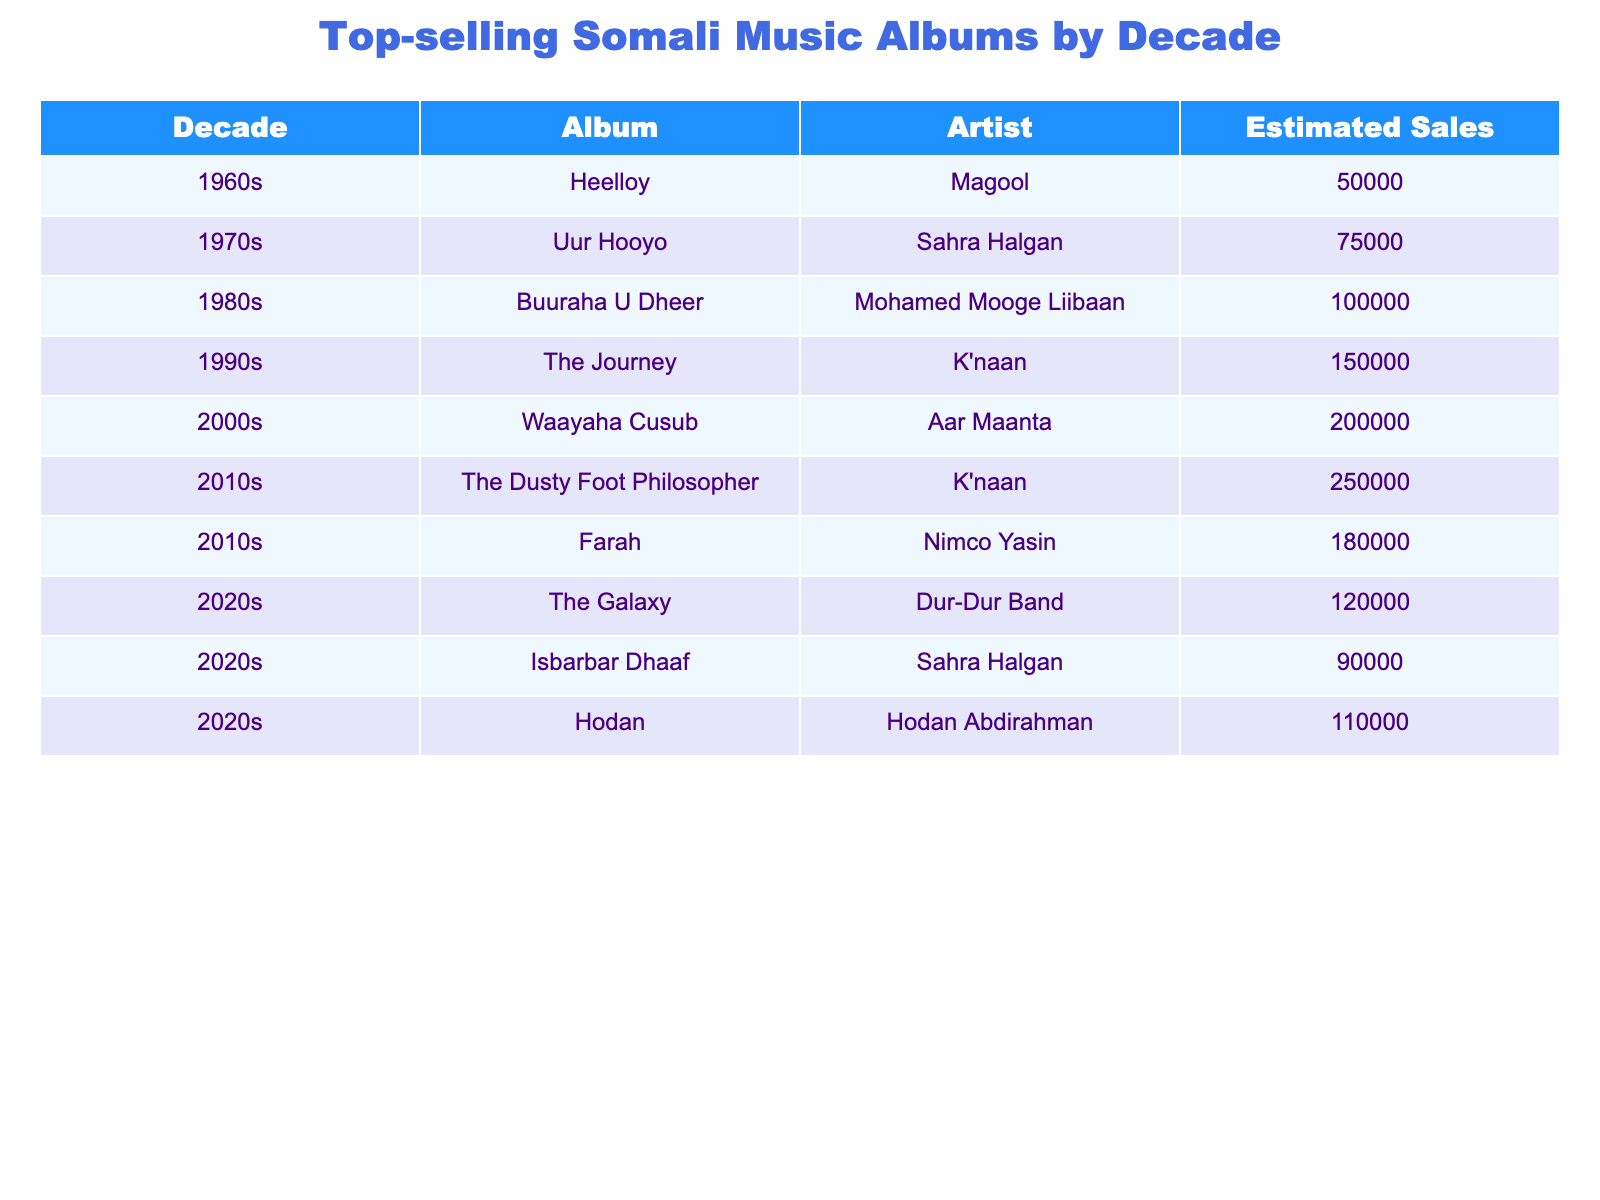What is the top-selling album of the 1990s? The album with the highest estimated sales in the 1990s is "The Journey" by K'naan, which has sales of 150,000.
Answer: 150,000 Which artist had the highest total estimated sales in the 2010s? The total estimated sales for K'naan in the 2010s are 250,000 from "The Dusty Foot Philosopher" and 180,000 from "Farah," totaling 430,000. No other artist in the 2010s exceeds this total.
Answer: K'naan What decade had the highest estimated sales album? The album with the highest estimated sales is "The Dusty Foot Philosopher" by K'naan from the 2010s, with 250,000 sales.
Answer: 2010s What is the average estimated sales of albums from the 2020s? The estimated sales from the 2020s are 120,000, 90,000, and 110,000. The average is (120,000 + 90,000 + 110,000) / 3 = 106,666.67, rounded to 106,667.
Answer: 106,667 Is Magool the only artist from the 1960s listed in the table? The table shows only one album from the 1960s, which is "Heelloy" by Magool, confirming that she is the only artist from that decade in the table.
Answer: Yes Which decade saw the release of "Waayaha Cusub"? The album "Waayaha Cusub" by Aar Maanta was released in the 2000s, according to the data provided.
Answer: 2000s If you sum the estimated sales of the albums from the 1980s and 1990s, what is the total? The estimated sales for "Buuraha U Dheer" in the 1980s are 100,000 and for "The Journey" in the 1990s are 150,000. Summing them gives 100,000 + 150,000 = 250,000.
Answer: 250,000 How many albums in the table were performed by K'naan? K'naan has two albums credited in the table: "The Journey" from the 1990s and "The Dusty Foot Philosopher" from the 2010s.
Answer: 2 Which artist has the album with the lowest estimated sales in the 1970s? The album "Uur Hooyo" by Sahra Halgan is the only album listed for the 1970s with estimated sales of 75,000, making it the lowest for that decade.
Answer: 75,000 Are there any albums in the table with estimated sales over 200,000? Yes, there are two albums with sales over 200,000: "Waayaha Cusub" by Aar Maanta (200,000) and "The Dusty Foot Philosopher" by K'naan (250,000).
Answer: Yes 